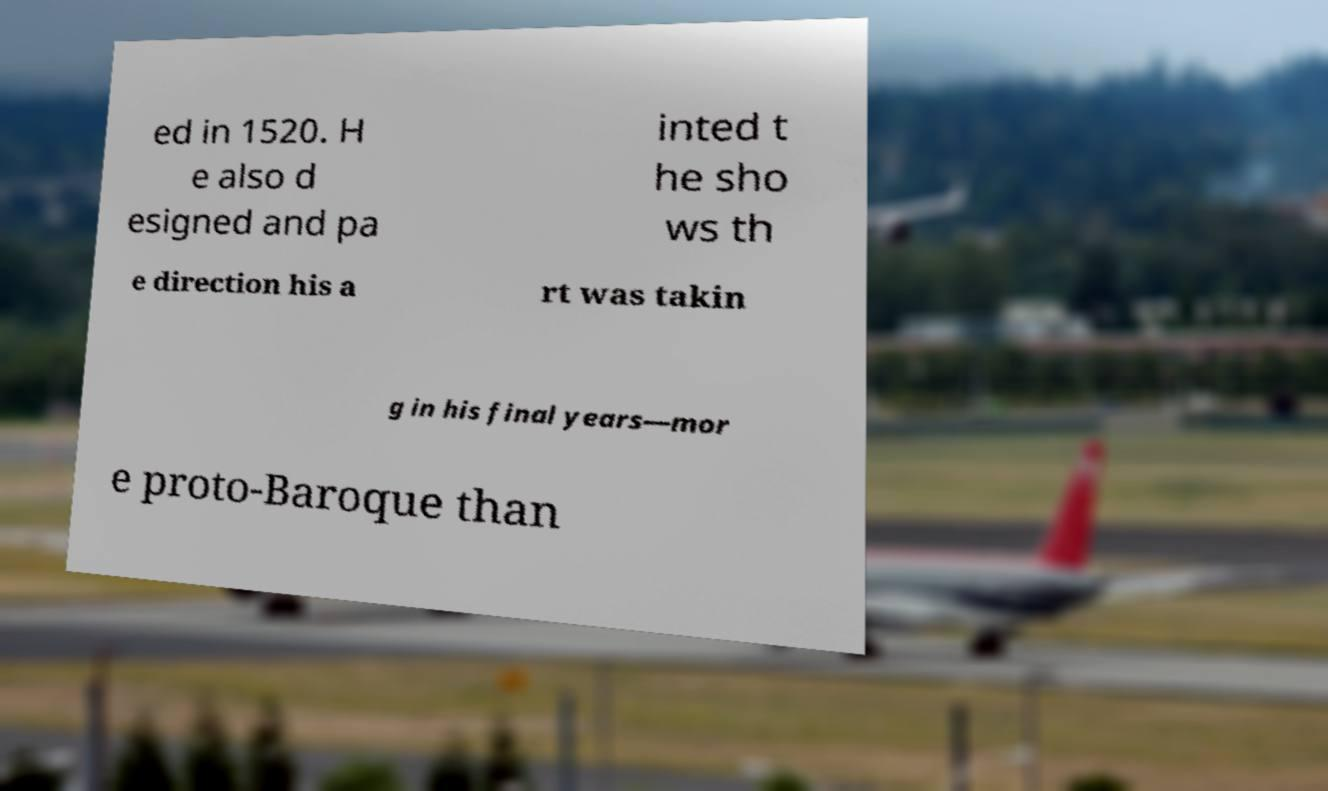Can you read and provide the text displayed in the image?This photo seems to have some interesting text. Can you extract and type it out for me? ed in 1520. H e also d esigned and pa inted t he sho ws th e direction his a rt was takin g in his final years—mor e proto-Baroque than 